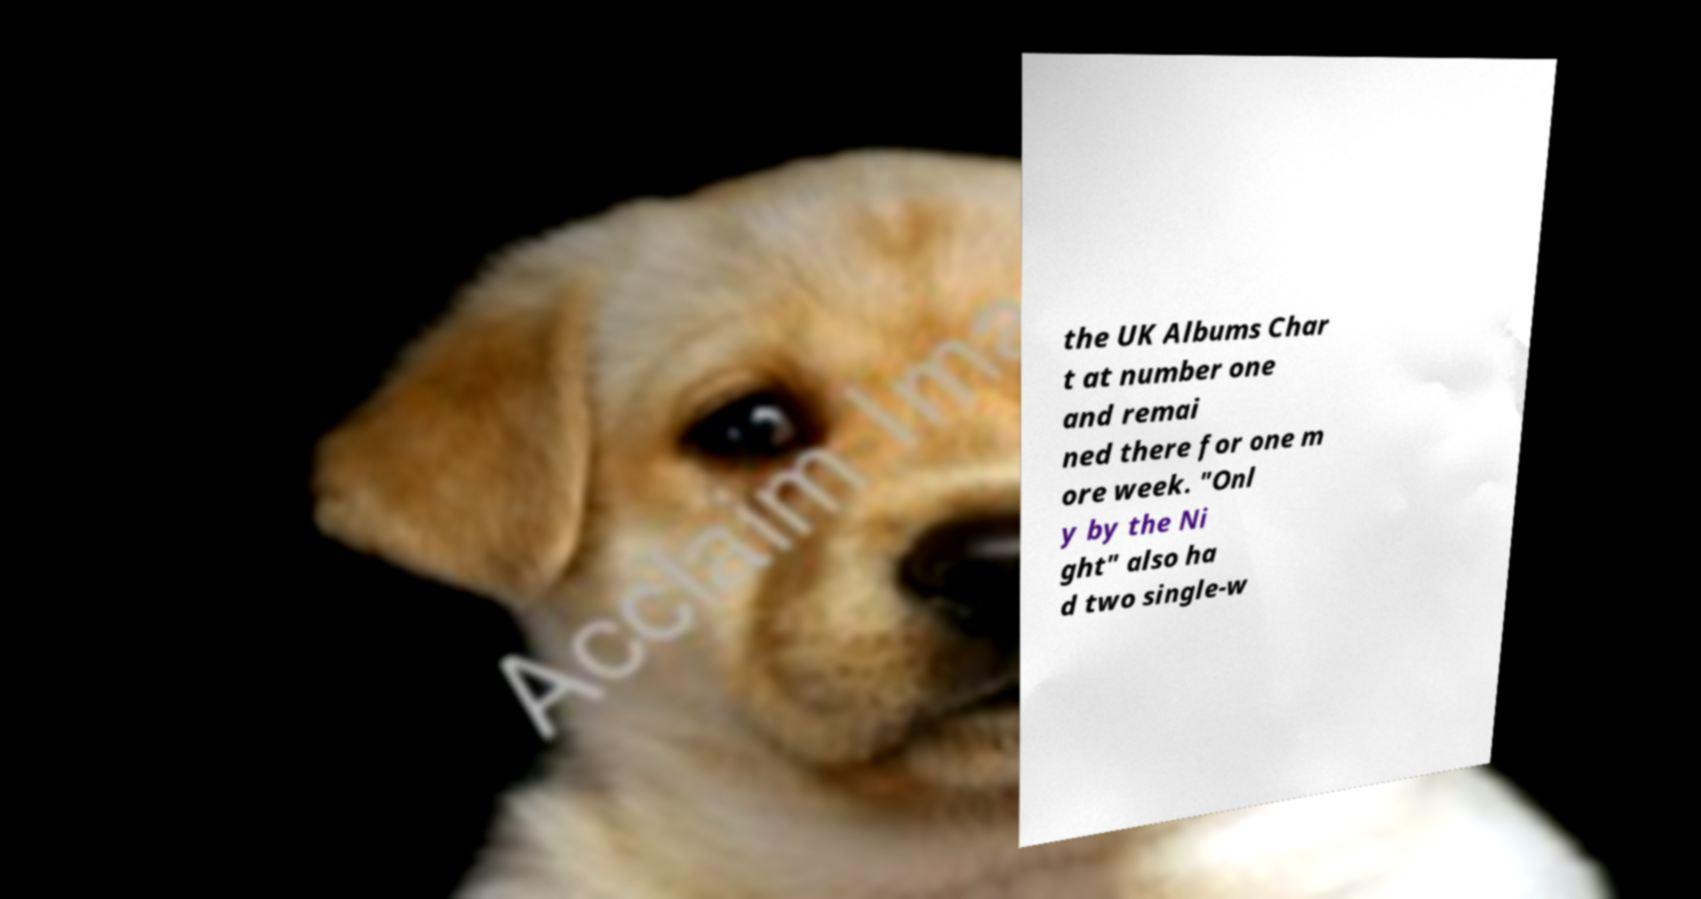I need the written content from this picture converted into text. Can you do that? the UK Albums Char t at number one and remai ned there for one m ore week. "Onl y by the Ni ght" also ha d two single-w 